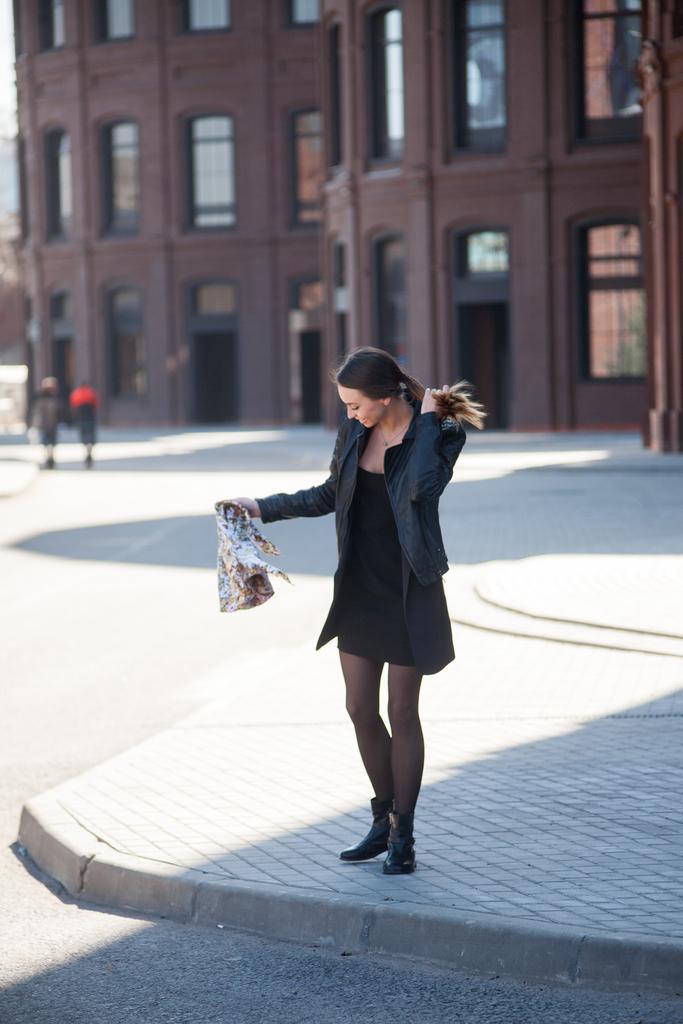How would you summarize this image in a sentence or two? Here we can see a woman on the platform. This is a road and there are two persons. In the background we can see a building. 